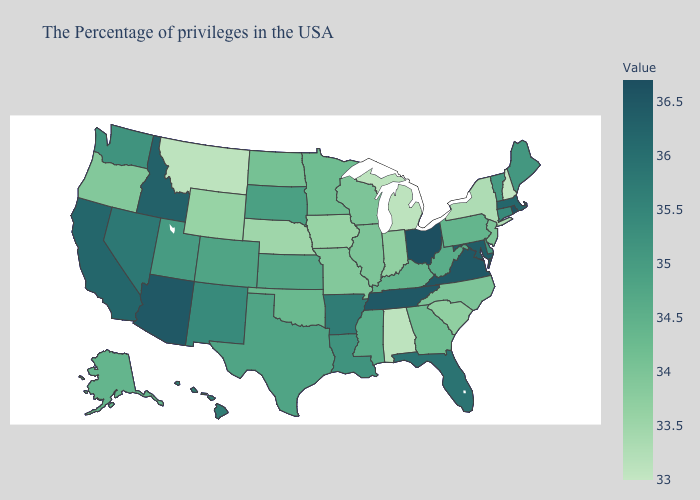Which states have the lowest value in the South?
Write a very short answer. Alabama. Does New Mexico have the highest value in the West?
Concise answer only. No. Among the states that border New Jersey , which have the highest value?
Give a very brief answer. Delaware. Which states have the highest value in the USA?
Quick response, please. Ohio. Is the legend a continuous bar?
Concise answer only. Yes. Is the legend a continuous bar?
Write a very short answer. Yes. Is the legend a continuous bar?
Short answer required. Yes. Does Ohio have the highest value in the MidWest?
Give a very brief answer. Yes. Does Rhode Island have the highest value in the Northeast?
Be succinct. Yes. 